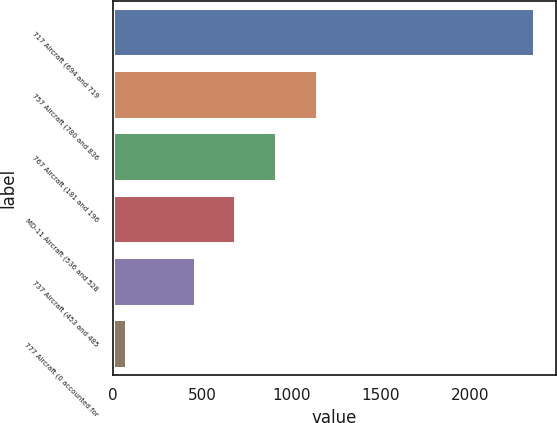<chart> <loc_0><loc_0><loc_500><loc_500><bar_chart><fcel>717 Aircraft (694 and 719<fcel>757 Aircraft (780 and 836<fcel>767 Aircraft (181 and 196<fcel>MD-11 Aircraft (536 and 528<fcel>737 Aircraft (453 and 485<fcel>777 Aircraft (0 accounted for<nl><fcel>2365<fcel>1149.2<fcel>920.8<fcel>692.4<fcel>464<fcel>81<nl></chart> 